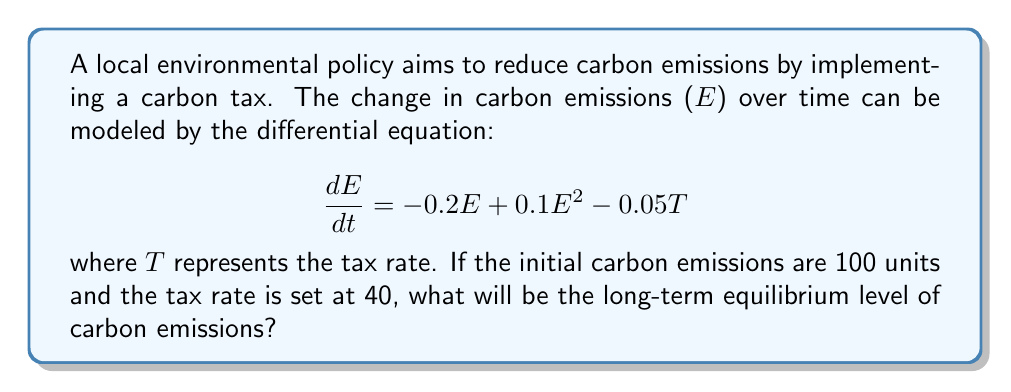Teach me how to tackle this problem. To find the long-term equilibrium level of carbon emissions, we need to follow these steps:

1. Set the differential equation equal to zero, as equilibrium occurs when there is no change over time:

   $$\frac{dE}{dt} = 0 = -0.2E + 0.1E^2 - 0.05T$$

2. Substitute the given tax rate $T = 40$:

   $$0 = -0.2E + 0.1E^2 - 0.05(40)$$
   $$0 = -0.2E + 0.1E^2 - 2$$

3. Rearrange the equation to standard quadratic form:

   $$0.1E^2 - 0.2E - 2 = 0$$

4. Solve the quadratic equation using the quadratic formula:

   $$E = \frac{-b \pm \sqrt{b^2 - 4ac}}{2a}$$

   Where $a = 0.1$, $b = -0.2$, and $c = -2$

5. Calculate:

   $$E = \frac{0.2 \pm \sqrt{(-0.2)^2 - 4(0.1)(-2)}}{2(0.1)}$$
   $$E = \frac{0.2 \pm \sqrt{0.04 + 0.8}}{0.2}$$
   $$E = \frac{0.2 \pm \sqrt{0.84}}{0.2}$$
   $$E = \frac{0.2 \pm 0.9165}{0.2}$$

6. This gives us two solutions:

   $$E_1 = \frac{0.2 + 0.9165}{0.2} = 5.5825$$
   $$E_2 = \frac{0.2 - 0.9165}{0.2} = -3.5825$$

7. Since carbon emissions cannot be negative, we discard the negative solution.

Therefore, the long-term equilibrium level of carbon emissions is approximately 5.5825 units.
Answer: 5.5825 units 